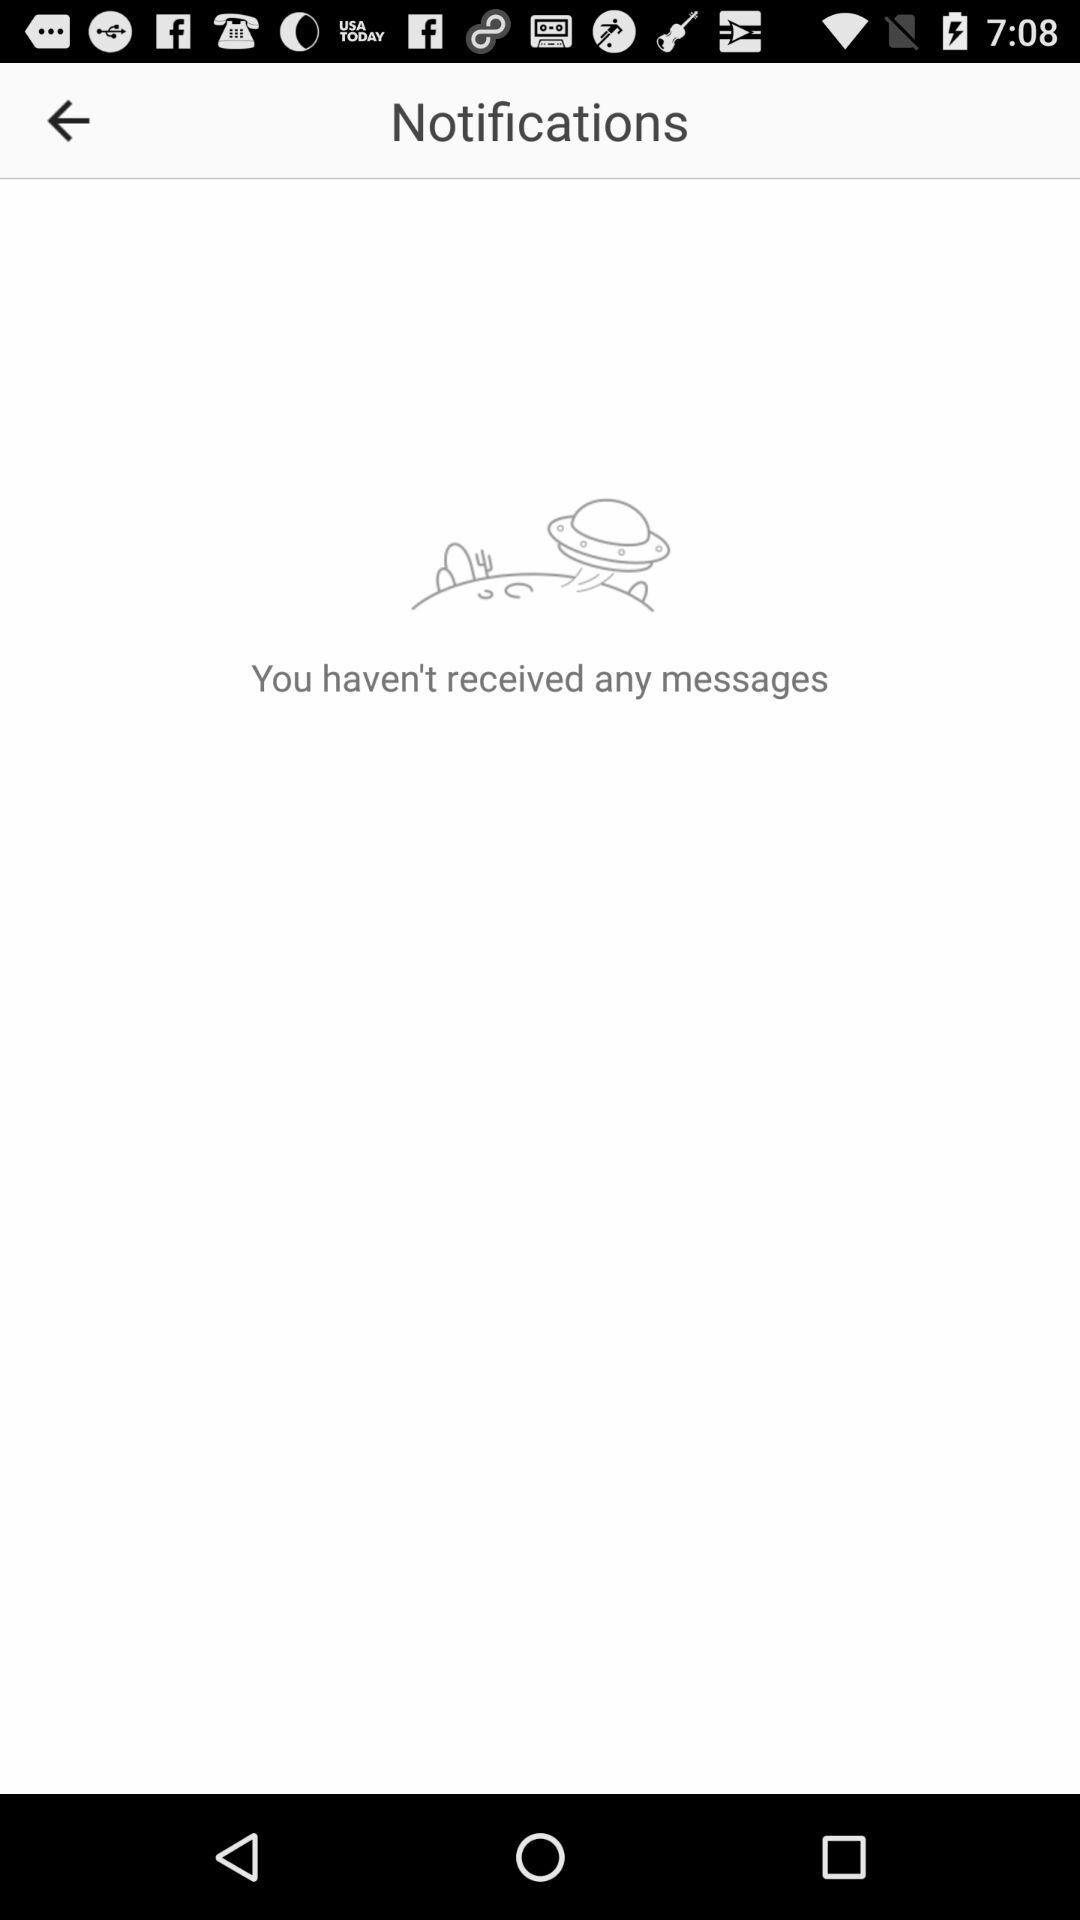How many messages are received? There are no messages received. 